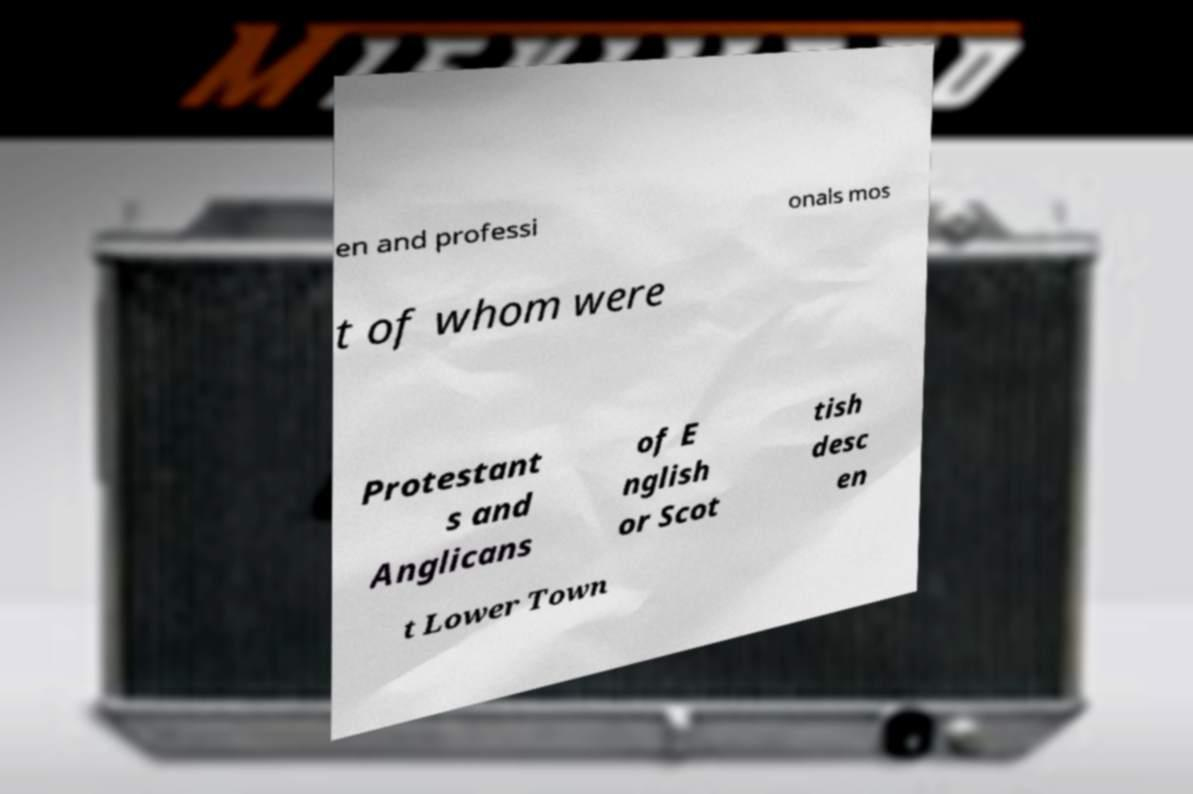For documentation purposes, I need the text within this image transcribed. Could you provide that? en and professi onals mos t of whom were Protestant s and Anglicans of E nglish or Scot tish desc en t Lower Town 